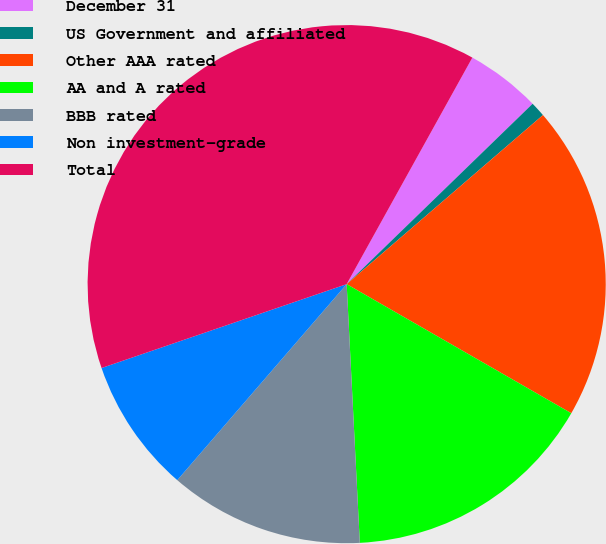Convert chart. <chart><loc_0><loc_0><loc_500><loc_500><pie_chart><fcel>December 31<fcel>US Government and affiliated<fcel>Other AAA rated<fcel>AA and A rated<fcel>BBB rated<fcel>Non investment-grade<fcel>Total<nl><fcel>4.68%<fcel>0.94%<fcel>19.62%<fcel>15.89%<fcel>12.15%<fcel>8.41%<fcel>38.31%<nl></chart> 